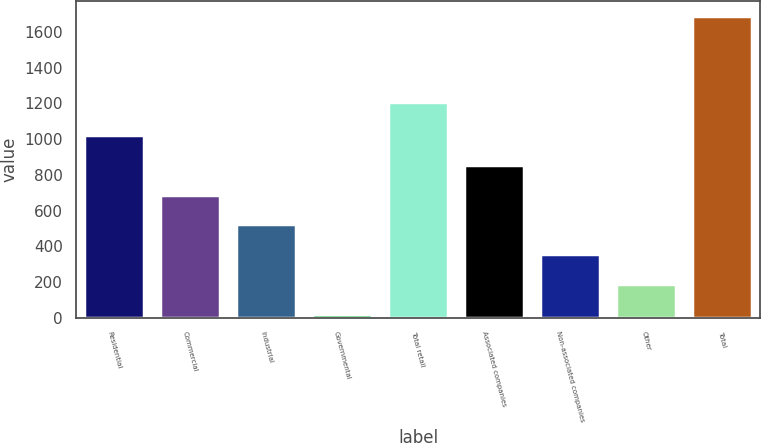Convert chart to OTSL. <chart><loc_0><loc_0><loc_500><loc_500><bar_chart><fcel>Residential<fcel>Commercial<fcel>Industrial<fcel>Governmental<fcel>Total retail<fcel>Associated companies<fcel>Non-associated companies<fcel>Other<fcel>Total<nl><fcel>1023.2<fcel>689.8<fcel>523.1<fcel>23<fcel>1208<fcel>856.5<fcel>356.4<fcel>189.7<fcel>1690<nl></chart> 